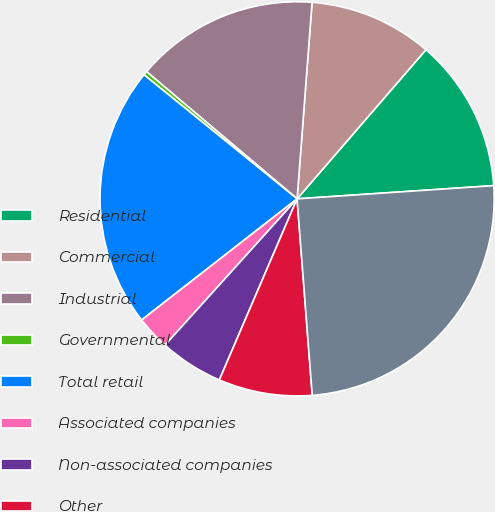Convert chart to OTSL. <chart><loc_0><loc_0><loc_500><loc_500><pie_chart><fcel>Residential<fcel>Commercial<fcel>Industrial<fcel>Governmental<fcel>Total retail<fcel>Associated companies<fcel>Non-associated companies<fcel>Other<fcel>Total<nl><fcel>12.59%<fcel>10.13%<fcel>15.04%<fcel>0.33%<fcel>21.37%<fcel>2.78%<fcel>5.23%<fcel>7.68%<fcel>24.84%<nl></chart> 